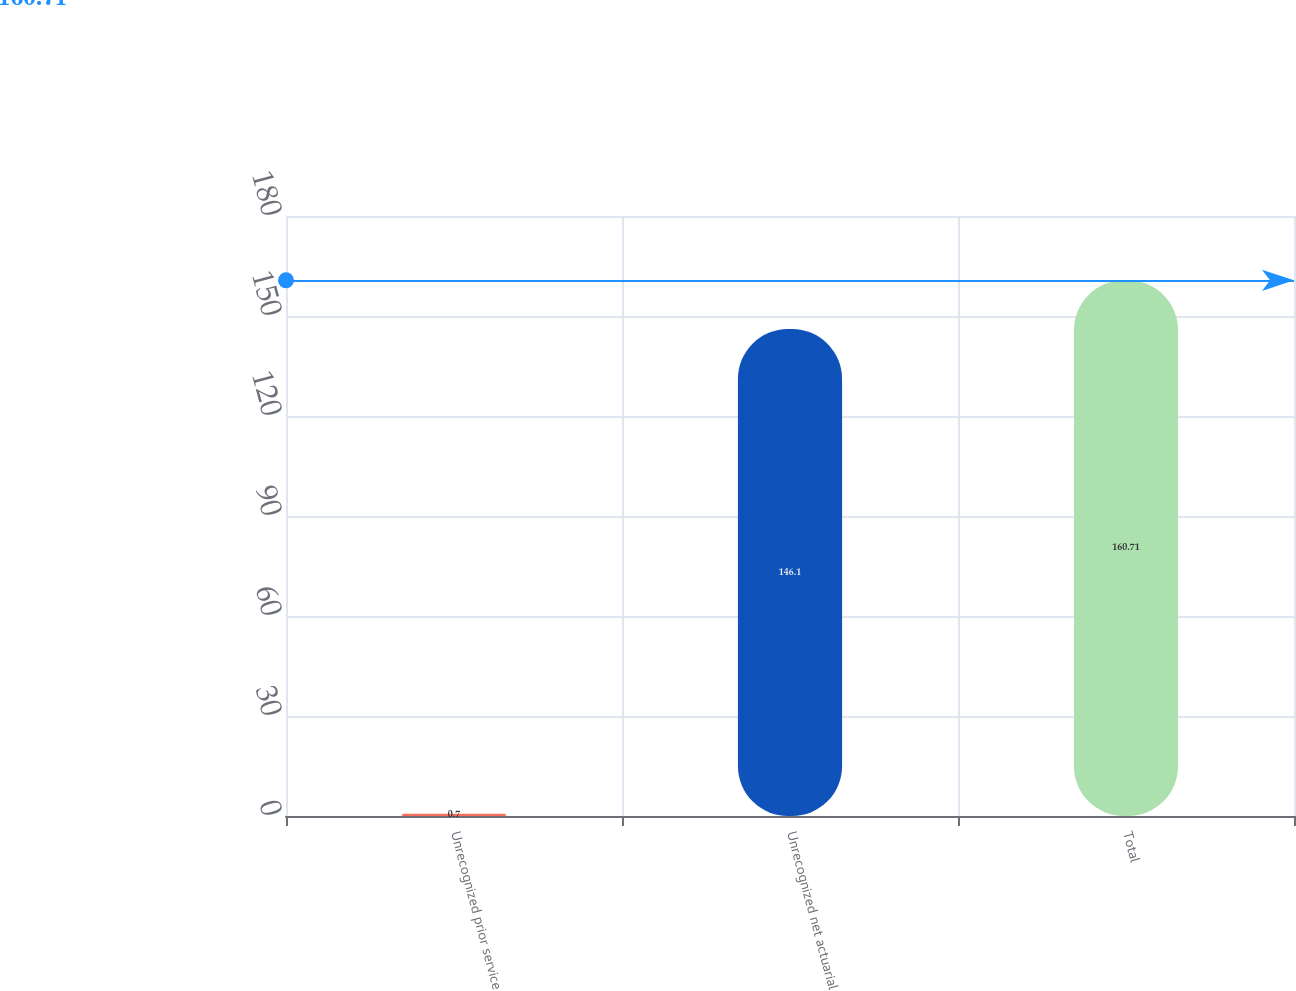Convert chart to OTSL. <chart><loc_0><loc_0><loc_500><loc_500><bar_chart><fcel>Unrecognized prior service<fcel>Unrecognized net actuarial<fcel>Total<nl><fcel>0.7<fcel>146.1<fcel>160.71<nl></chart> 